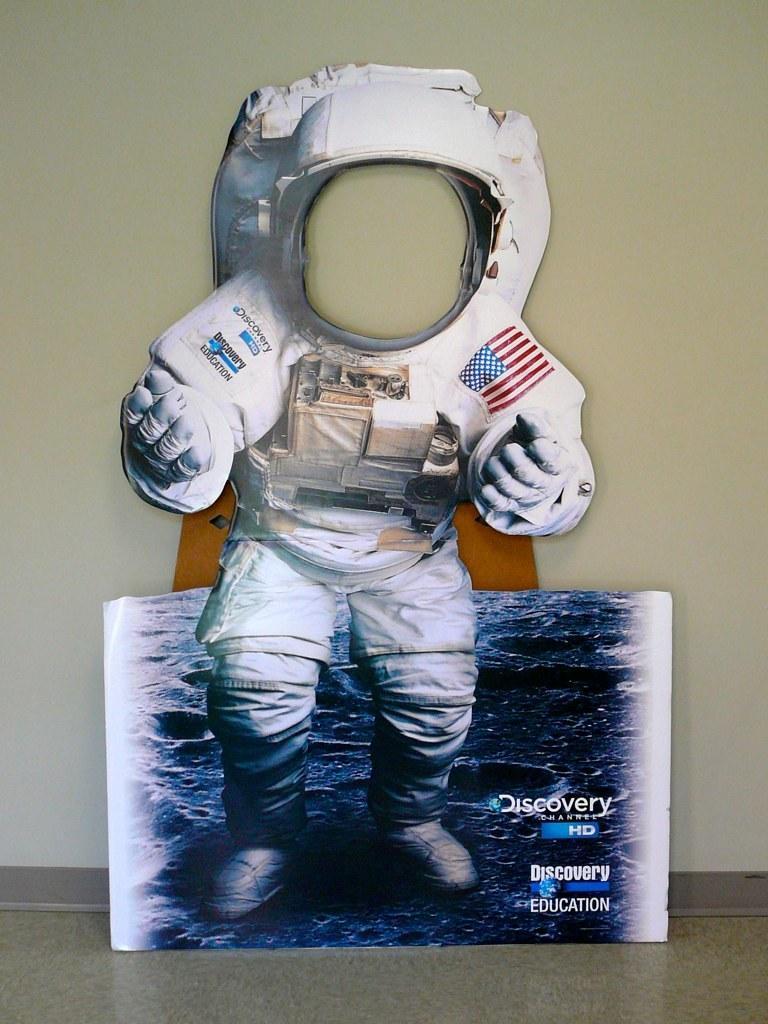Could you give a brief overview of what you see in this image? This picture might be taken inside the room. In this image, in the middle, we can see a image of an astronaut and a board. In the background, we can see a wall. 